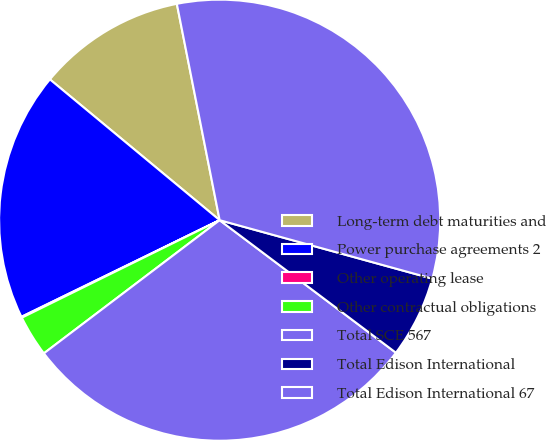Convert chart to OTSL. <chart><loc_0><loc_0><loc_500><loc_500><pie_chart><fcel>Long-term debt maturities and<fcel>Power purchase agreements 2<fcel>Other operating lease<fcel>Other contractual obligations<fcel>Total SCE 567<fcel>Total Edison International<fcel>Total Edison International 67<nl><fcel>10.87%<fcel>18.24%<fcel>0.07%<fcel>3.03%<fcel>29.42%<fcel>5.99%<fcel>32.38%<nl></chart> 